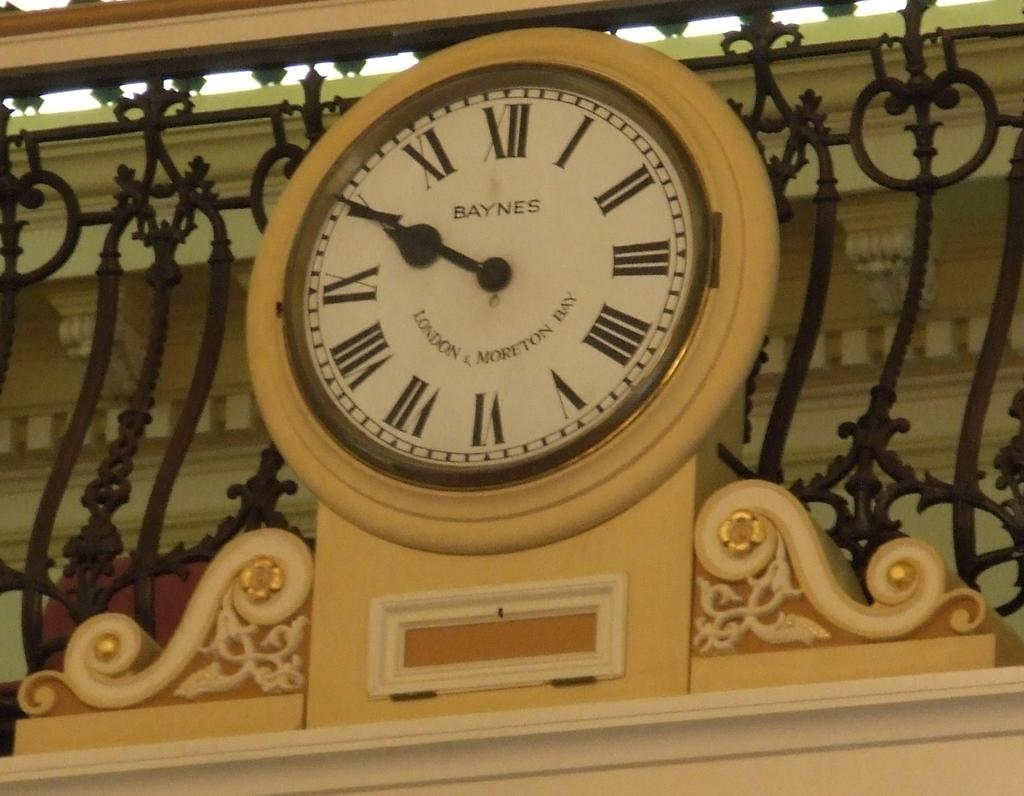<image>
Provide a brief description of the given image. A Baynes clock sits against an iron fence and is painted yellow 